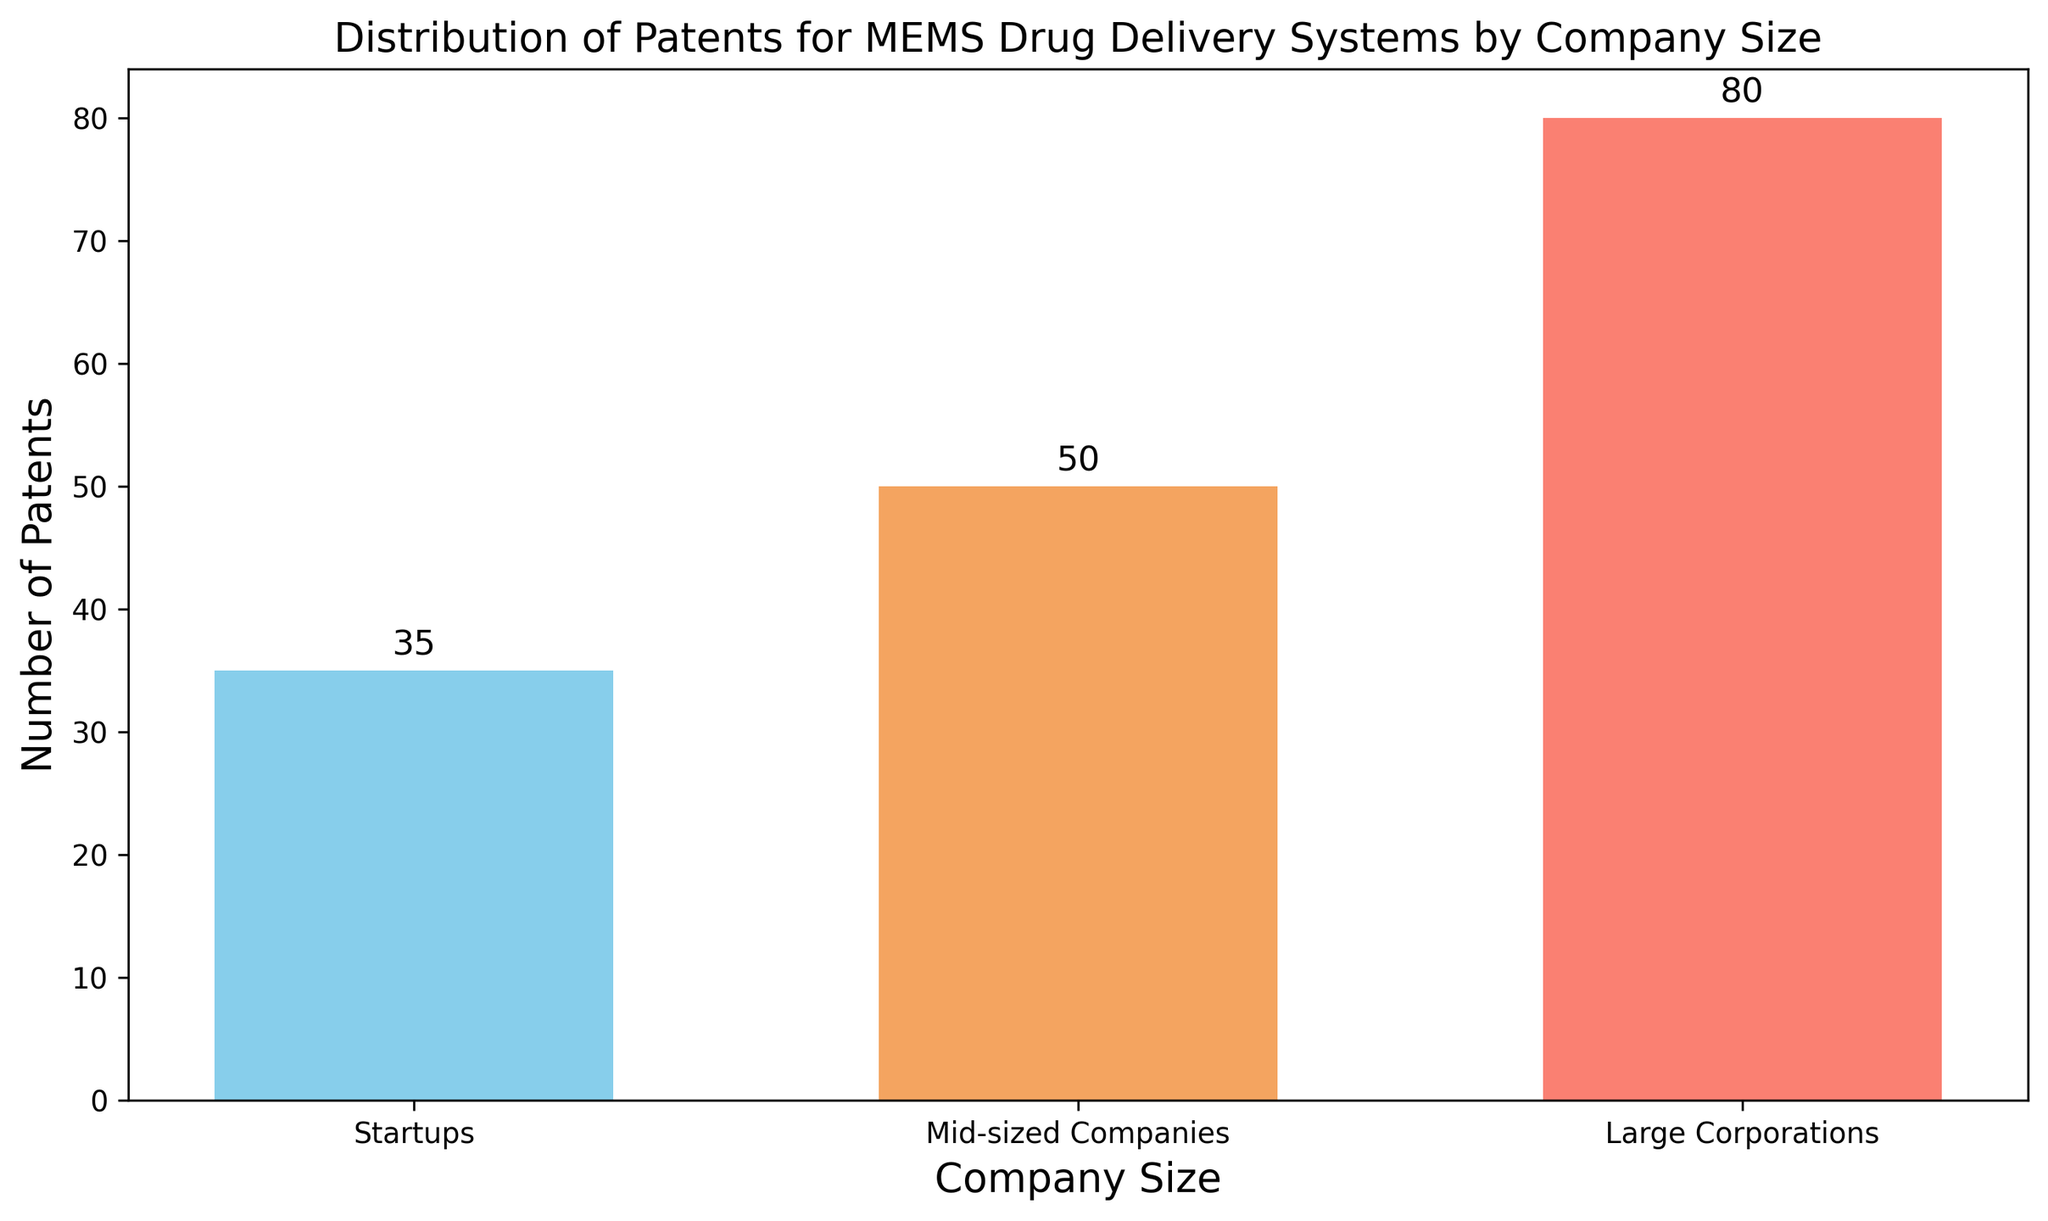Which company size group filed the most patents? By observing the height of the bars, the 'Large Corporations' group has the tallest bar, indicating they filed the most patents.
Answer: Large Corporations How many more patents did mid-sized companies file compared to startups? The bar for mid-sized companies represents 50 patents, and the bar for startups represents 35. The difference is 50 - 35 = 15.
Answer: 15 What is the total number of patents filed across all company sizes? Sum the heights of all the bars: 35 (startups) + 50 (mid-sized companies) + 80 (large corporations) = 165.
Answer: 165 Which group has the smallest number of patents filed? By comparing the heights of the bars, the 'Startups' group has the smallest bar, indicating the least number of patents.
Answer: Startups Are there more patents filed by mid-sized companies and large corporations combined than the total number of patents filed? Sum the patents of mid-sized companies (50) and large corporations (80): 50 + 80 = 130, and compare it to the total number (165).
Answer: No What is the difference in the number of patents between the group with the highest and the group with the lowest patents? The highest (Large Corporations) has 80 patents, and the lowest (Startups) has 35. The difference is 80 - 35 = 45.
Answer: 45 Which color represents the bar for the startups? The color of the bar corresponding to 'Startups' is the first one listed in the code, which is 'skyblue'.
Answer: Skyblue What percentage of the total patents filed were by large corporations? First, find the total number of patents (165). Then compute (80/165) * 100 to get approximately 48.48%.
Answer: 48.48% Are the number of patents filed by mid-sized companies and startups together more than the number of patents filed by large corporations? Sum patents of mid-sized companies (50) and startups (35): 50 + 35 = 85, compare it with large corporations (80).
Answer: Yes What is the number of patents filed by large corporations minus the number filed by mid-sized companies? Subtract the number of patents of mid-sized companies (50) from large corporations (80): 80 - 50 = 30.
Answer: 30 